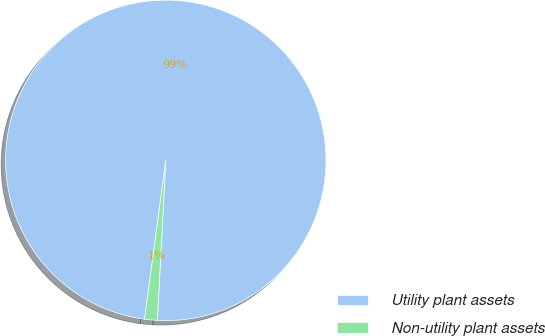<chart> <loc_0><loc_0><loc_500><loc_500><pie_chart><fcel>Utility plant assets<fcel>Non-utility plant assets<nl><fcel>98.73%<fcel>1.27%<nl></chart> 